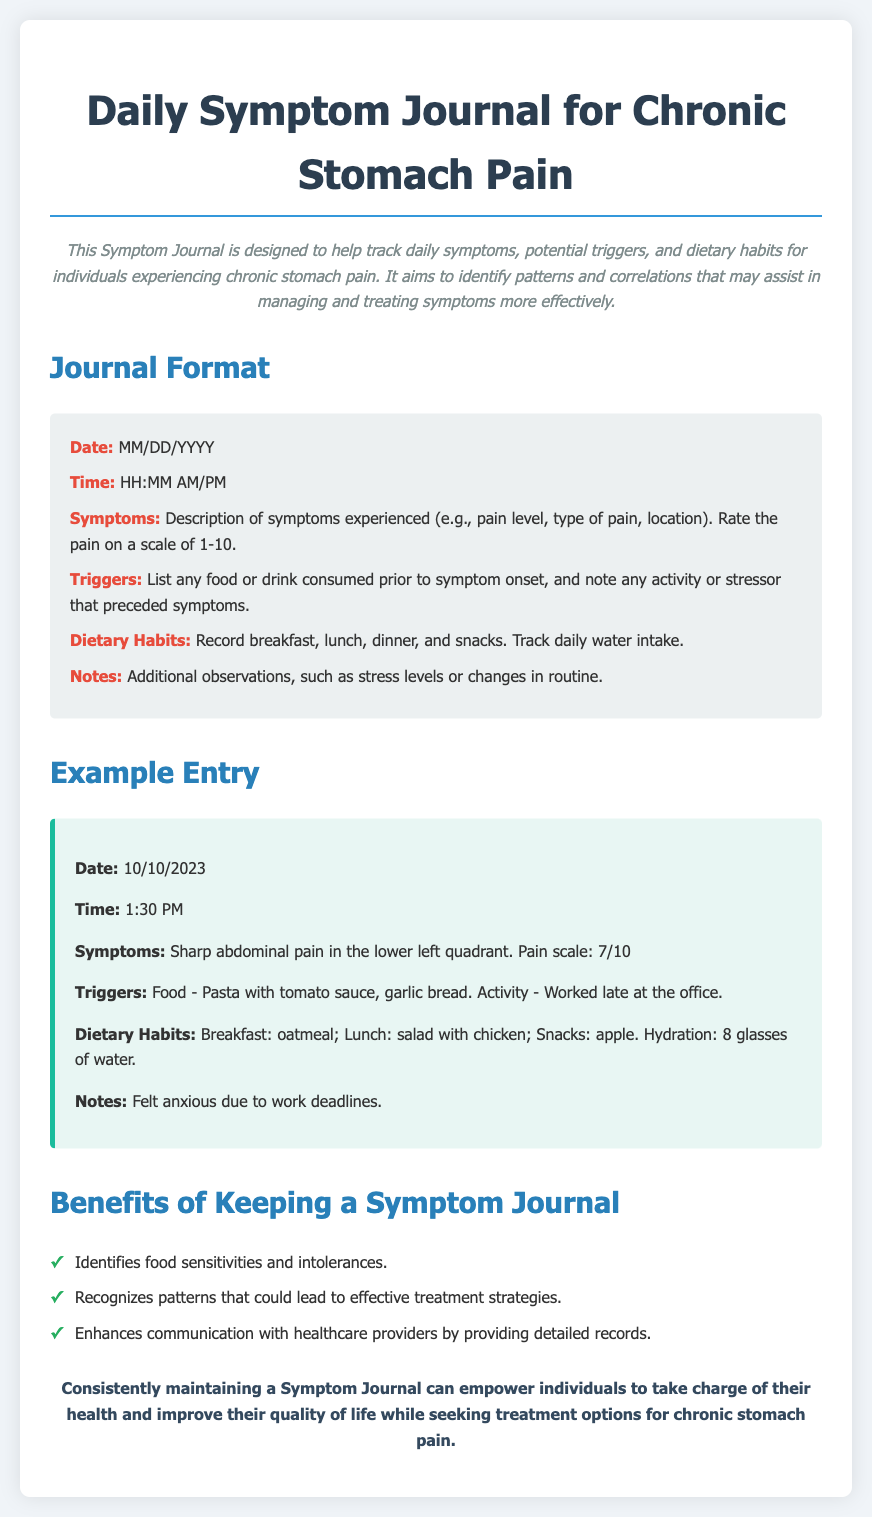what is the title of the document? The title is an important header that indicates the subject matter of the document.
Answer: Daily Symptom Journal for Chronic Stomach Pain what date format should be used in the journal? The date format is mentioned in the journal format section.
Answer: MM/DD/YYYY what are the symptoms expected to be recorded? The symptoms section outlines what information needs to be included regarding health issues.
Answer: Description of symptoms experienced (e.g., pain level, type of pain, location) how does one record dietary habits? The dietary habits section specifies what meals and fluid intake should be documented.
Answer: Record breakfast, lunch, dinner, and snacks. Track daily water intake what type of entry is included as an example? The example entry serves to illustrate the type of information to be logged in the journal.
Answer: Sharp abdominal pain in the lower left quadrant. Pain scale: 7/10 what is one benefit of keeping a symptom journal? The benefits section summarizes the positive outcomes of maintaining the journal.
Answer: Identifies food sensitivities and intolerances what should be noted in the “Notes” section? The notes section details additional observations that may affect health.
Answer: Additional observations, such as stress levels or changes in routine which food triggered symptoms in the example entry? The example entry lists specific foods consumed that are relevant to symptom onset.
Answer: Pasta with tomato sauce, garlic bread what should be included in the journal about triggers? Triggers are important for understanding what may contribute to symptoms, as indicated in the format section.
Answer: List any food or drink consumed prior to symptom onset, and note any activity or stressor that preceded symptoms 